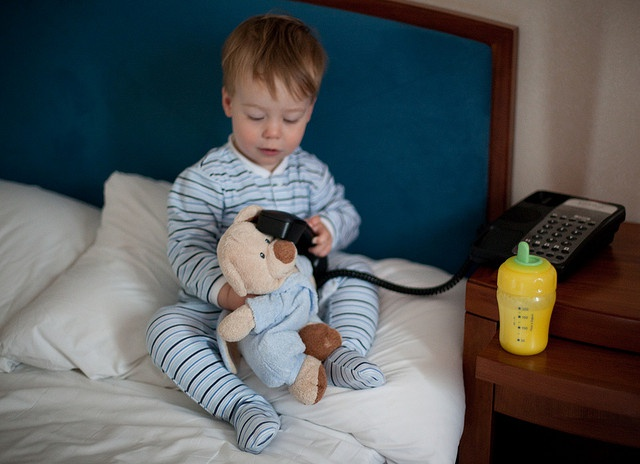Describe the objects in this image and their specific colors. I can see bed in black, darkgray, darkblue, and gray tones, people in black, darkgray, and gray tones, teddy bear in black, darkgray, tan, and lightblue tones, and teddy bear in black, darkgray, gray, and tan tones in this image. 